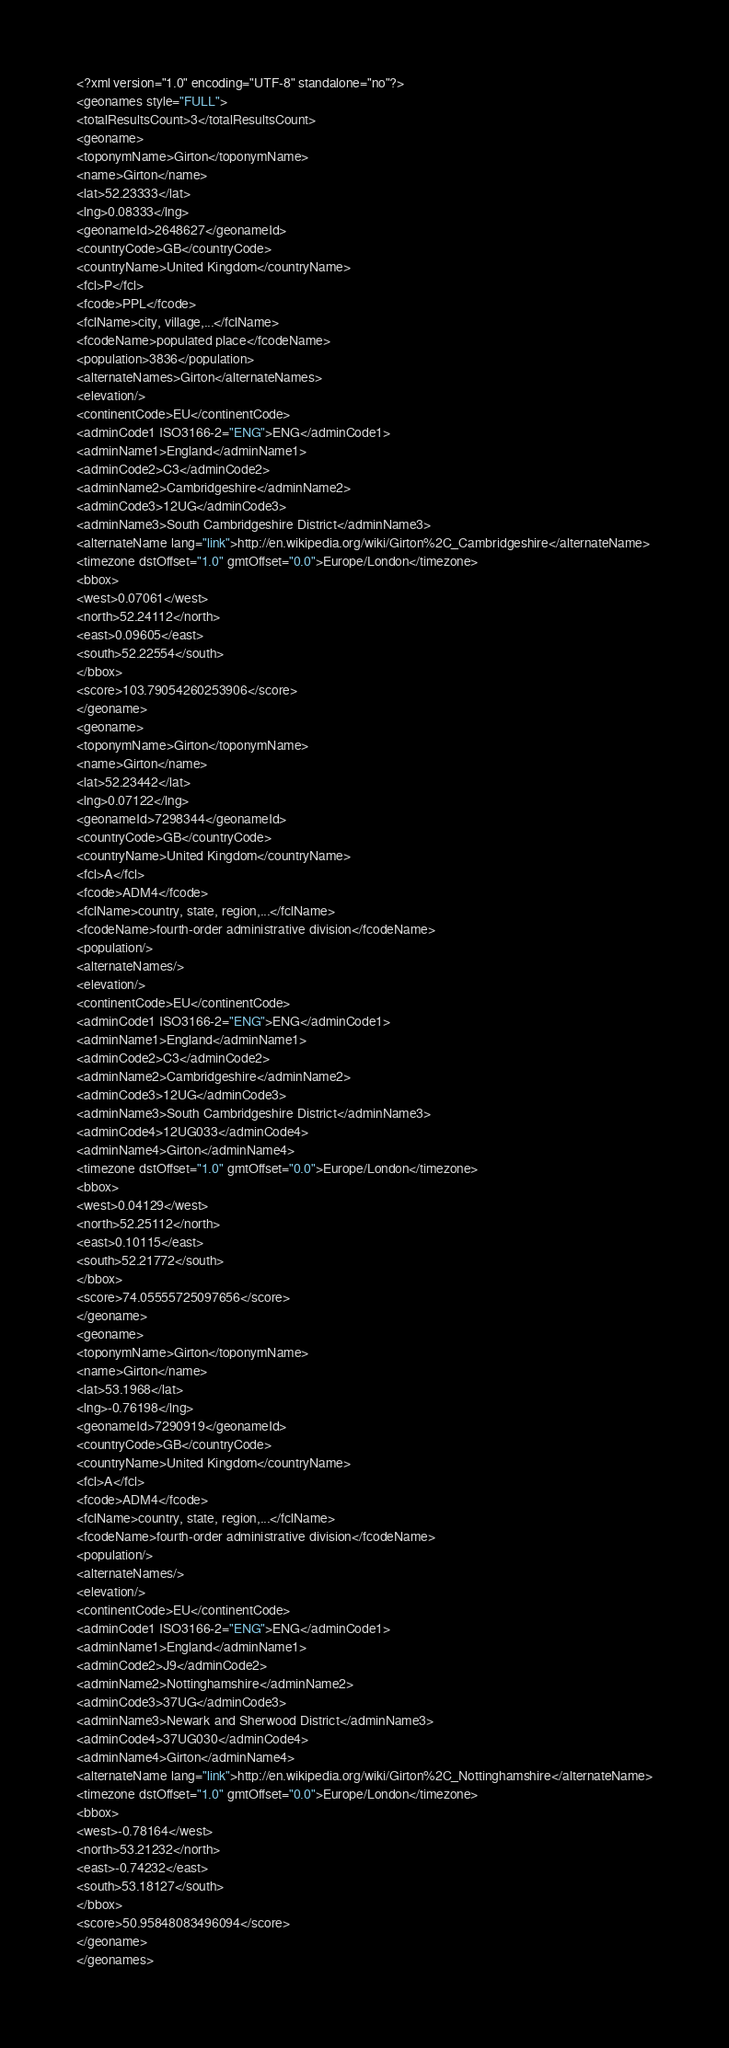<code> <loc_0><loc_0><loc_500><loc_500><_XML_><?xml version="1.0" encoding="UTF-8" standalone="no"?>
<geonames style="FULL">
<totalResultsCount>3</totalResultsCount>
<geoname>
<toponymName>Girton</toponymName>
<name>Girton</name>
<lat>52.23333</lat>
<lng>0.08333</lng>
<geonameId>2648627</geonameId>
<countryCode>GB</countryCode>
<countryName>United Kingdom</countryName>
<fcl>P</fcl>
<fcode>PPL</fcode>
<fclName>city, village,...</fclName>
<fcodeName>populated place</fcodeName>
<population>3836</population>
<alternateNames>Girton</alternateNames>
<elevation/>
<continentCode>EU</continentCode>
<adminCode1 ISO3166-2="ENG">ENG</adminCode1>
<adminName1>England</adminName1>
<adminCode2>C3</adminCode2>
<adminName2>Cambridgeshire</adminName2>
<adminCode3>12UG</adminCode3>
<adminName3>South Cambridgeshire District</adminName3>
<alternateName lang="link">http://en.wikipedia.org/wiki/Girton%2C_Cambridgeshire</alternateName>
<timezone dstOffset="1.0" gmtOffset="0.0">Europe/London</timezone>
<bbox>
<west>0.07061</west>
<north>52.24112</north>
<east>0.09605</east>
<south>52.22554</south>
</bbox>
<score>103.79054260253906</score>
</geoname>
<geoname>
<toponymName>Girton</toponymName>
<name>Girton</name>
<lat>52.23442</lat>
<lng>0.07122</lng>
<geonameId>7298344</geonameId>
<countryCode>GB</countryCode>
<countryName>United Kingdom</countryName>
<fcl>A</fcl>
<fcode>ADM4</fcode>
<fclName>country, state, region,...</fclName>
<fcodeName>fourth-order administrative division</fcodeName>
<population/>
<alternateNames/>
<elevation/>
<continentCode>EU</continentCode>
<adminCode1 ISO3166-2="ENG">ENG</adminCode1>
<adminName1>England</adminName1>
<adminCode2>C3</adminCode2>
<adminName2>Cambridgeshire</adminName2>
<adminCode3>12UG</adminCode3>
<adminName3>South Cambridgeshire District</adminName3>
<adminCode4>12UG033</adminCode4>
<adminName4>Girton</adminName4>
<timezone dstOffset="1.0" gmtOffset="0.0">Europe/London</timezone>
<bbox>
<west>0.04129</west>
<north>52.25112</north>
<east>0.10115</east>
<south>52.21772</south>
</bbox>
<score>74.05555725097656</score>
</geoname>
<geoname>
<toponymName>Girton</toponymName>
<name>Girton</name>
<lat>53.1968</lat>
<lng>-0.76198</lng>
<geonameId>7290919</geonameId>
<countryCode>GB</countryCode>
<countryName>United Kingdom</countryName>
<fcl>A</fcl>
<fcode>ADM4</fcode>
<fclName>country, state, region,...</fclName>
<fcodeName>fourth-order administrative division</fcodeName>
<population/>
<alternateNames/>
<elevation/>
<continentCode>EU</continentCode>
<adminCode1 ISO3166-2="ENG">ENG</adminCode1>
<adminName1>England</adminName1>
<adminCode2>J9</adminCode2>
<adminName2>Nottinghamshire</adminName2>
<adminCode3>37UG</adminCode3>
<adminName3>Newark and Sherwood District</adminName3>
<adminCode4>37UG030</adminCode4>
<adminName4>Girton</adminName4>
<alternateName lang="link">http://en.wikipedia.org/wiki/Girton%2C_Nottinghamshire</alternateName>
<timezone dstOffset="1.0" gmtOffset="0.0">Europe/London</timezone>
<bbox>
<west>-0.78164</west>
<north>53.21232</north>
<east>-0.74232</east>
<south>53.18127</south>
</bbox>
<score>50.95848083496094</score>
</geoname>
</geonames>
</code> 